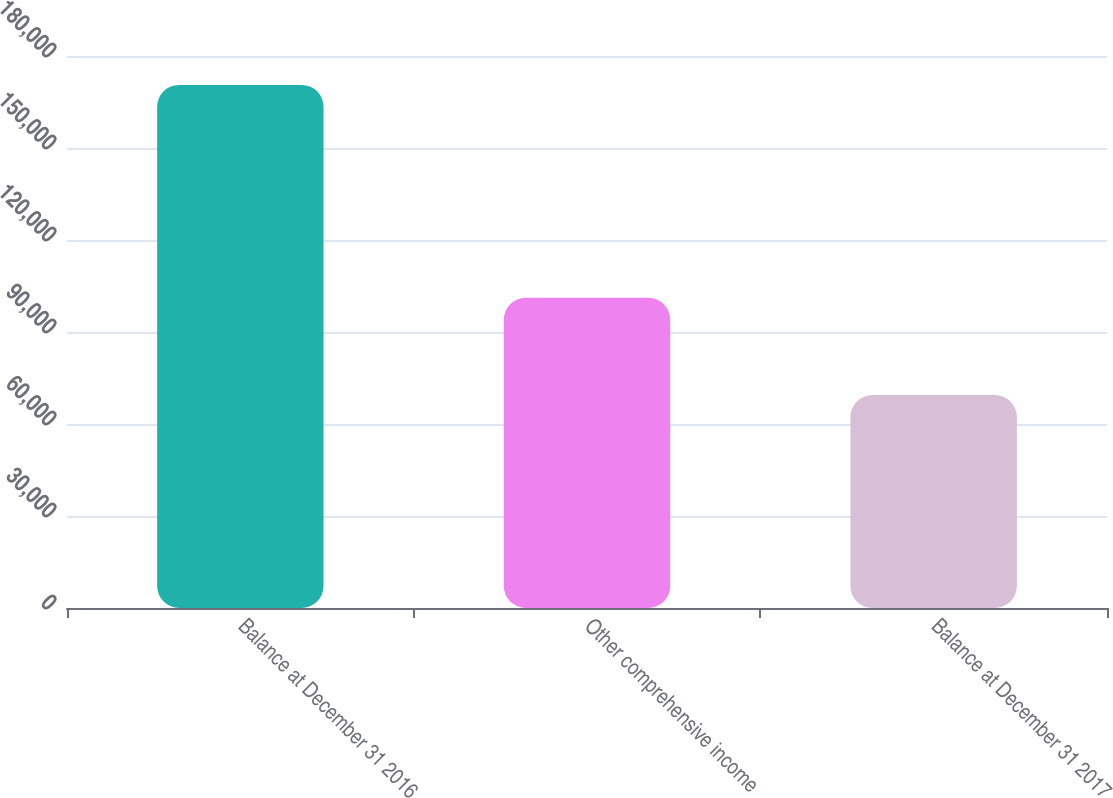Convert chart to OTSL. <chart><loc_0><loc_0><loc_500><loc_500><bar_chart><fcel>Balance at December 31 2016<fcel>Other comprehensive income<fcel>Balance at December 31 2017<nl><fcel>170566<fcel>101148<fcel>69418<nl></chart> 